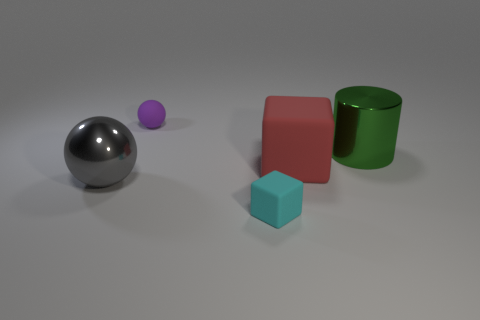How big is the rubber object that is left of the matte block in front of the large sphere?
Offer a terse response. Small. What is the size of the purple rubber thing behind the rubber cube to the left of the large red rubber block that is on the right side of the cyan thing?
Offer a very short reply. Small. There is a sphere in front of the big shiny thing that is on the right side of the big red object; is there a tiny matte thing that is to the left of it?
Offer a very short reply. No. Do the red rubber object and the green metal object have the same size?
Offer a terse response. Yes. Is the number of cyan things that are in front of the small block the same as the number of rubber cubes left of the red object?
Provide a short and direct response. No. What shape is the big thing behind the red matte object?
Your answer should be very brief. Cylinder. There is a green shiny object that is the same size as the red object; what is its shape?
Offer a terse response. Cylinder. The small matte object that is behind the sphere that is left of the tiny thing that is behind the small cyan matte object is what color?
Keep it short and to the point. Purple. Do the cyan thing and the red object have the same shape?
Offer a terse response. Yes. Are there the same number of large gray balls that are left of the big gray object and yellow matte objects?
Your answer should be very brief. Yes. 